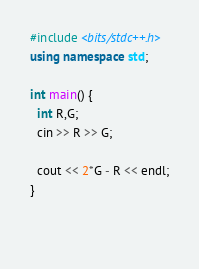Convert code to text. <code><loc_0><loc_0><loc_500><loc_500><_C++_>#include <bits/stdc++.h>
using namespace std;
 
int main() {
  int R,G;
  cin >> R >> G;
  
  cout << 2*G - R << endl;
}
  
  </code> 